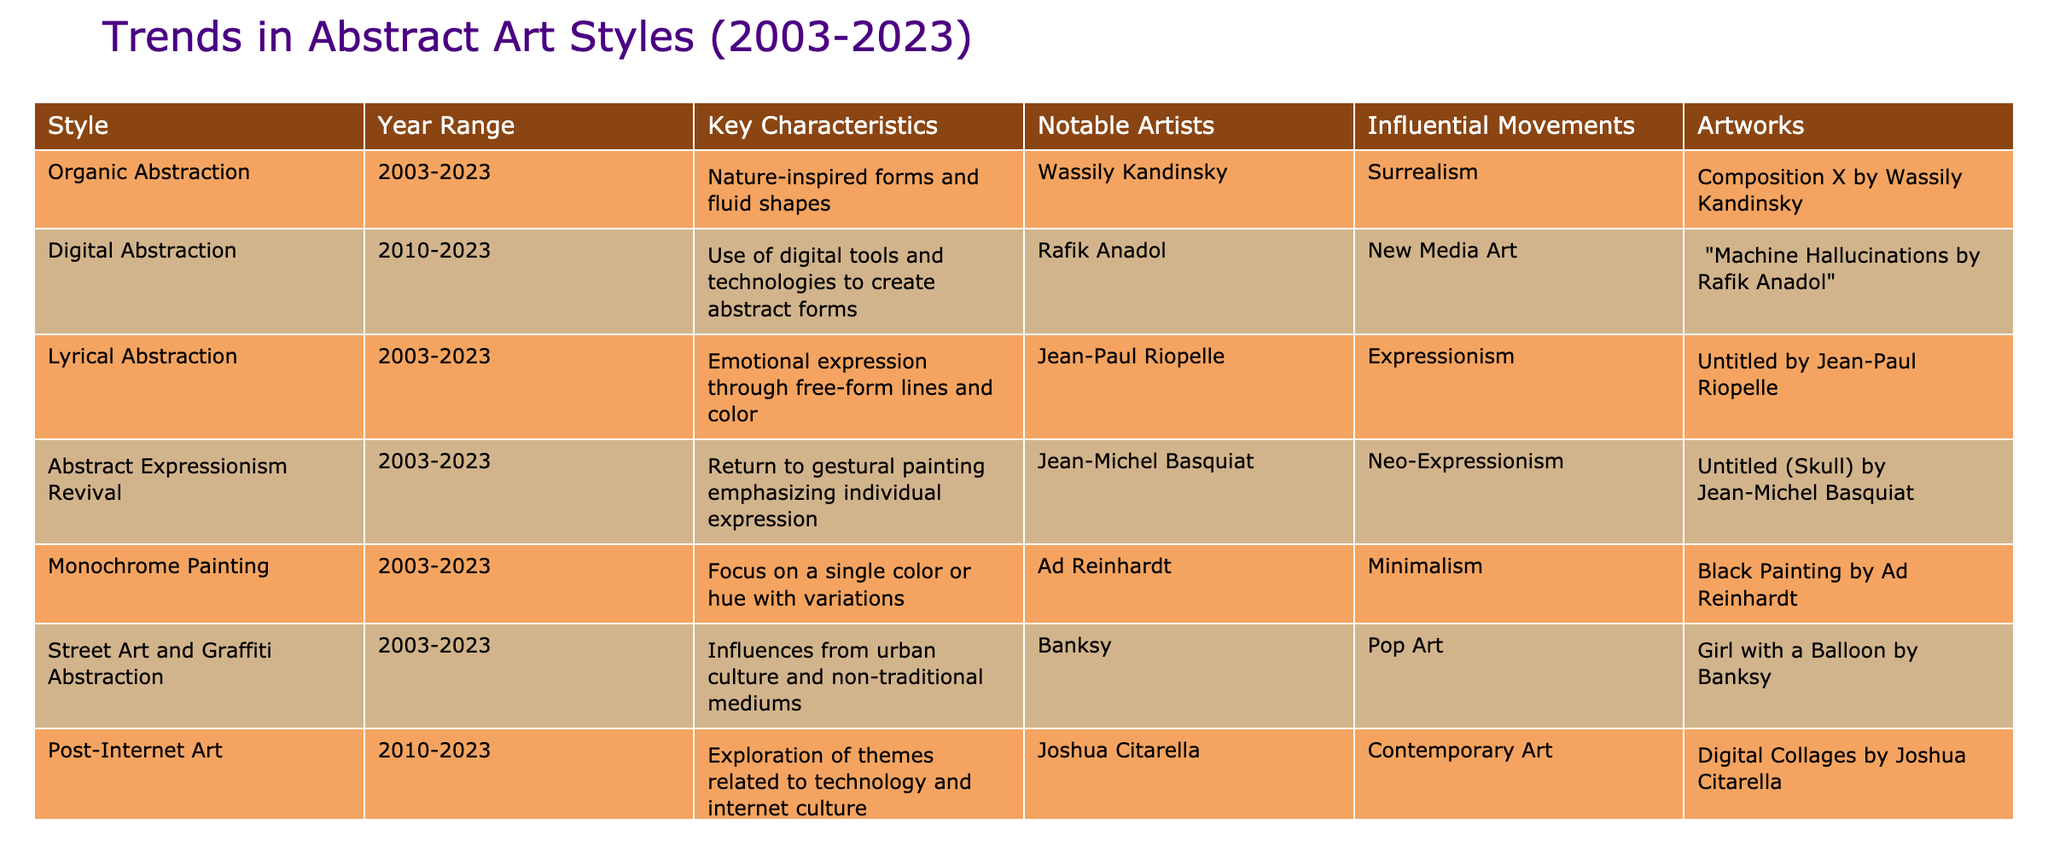What is the year range for Digital Abstraction? The table lists the year range for Digital Abstraction under the "Year Range" column, which specifically mentions 2010-2023.
Answer: 2010-2023 Which movement influenced Monochrome Painting? The table indicates that Monochrome Painting is influenced by the Minimalism movement, as stated in the "Influential Movements" column.
Answer: Minimalism How many styles are influenced by Expressionism? First, look at the "Influential Movements" column and identify the styles that mention Expressionism. These are Lyrical Abstraction and Abstract Expressionism Revival, which gives us a total of two styles.
Answer: 2 Is Street Art and Graffiti Abstraction characterized by traditional mediums? By checking the column "Key Characteristics" for Street Art and Graffiti Abstraction, it states that it is influenced by non-traditional mediums, which means the statement is false.
Answer: No What are the key characteristics of Organic Abstraction? The "Key Characteristics" column for Organic Abstraction specifies that it involves nature-inspired forms and fluid shapes, providing a clear definition of its traits.
Answer: Nature-inspired forms and fluid shapes Which notable artist is associated with the Abstract Expressionism Revival style? Referring to the "Notable Artists" column for Abstract Expressionism Revival, it is noted that Jean-Michel Basquiat is the associated artist.
Answer: Jean-Michel Basquiat How does Digital Abstraction differ from Abstract Photography? Digital Abstraction is characterized by the use of digital tools and technologies, while Abstract Photography focuses on creating non-representational imagery through photography. This implies a difference in the medium used to achieve abstraction.
Answer: Different mediums What is the relationship between Lyrical Abstraction and Expressionism? Lyrical Abstraction is influenced by Expressionism, as noted in the table. This connection suggests that Lyrical Abstraction shares elements of emotional expression that are key to the Expressionism movement.
Answer: Influenced by Expressionism How many notable artists are mentioned in the table? To find this, count the unique names in the "Notable Artists" column, which include: Wassily Kandinsky, Rafik Anadol, Jean-Paul Riopelle, Jean-Michel Basquiat, Ad Reinhardt, Banksy, and Joshua Citarella. This totals to seven distinctive artists, leading to the conclusion.
Answer: 7 